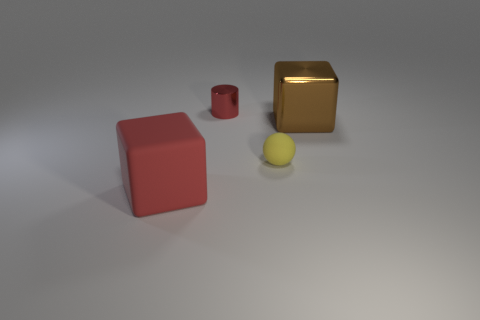What is the size of the object that is the same color as the big matte block?
Your answer should be compact. Small. What number of red things are left of the block that is on the right side of the red shiny cylinder?
Keep it short and to the point. 2. There is a yellow object; is it the same size as the rubber thing in front of the tiny yellow matte object?
Offer a very short reply. No. Are there any small cylinders of the same color as the big rubber cube?
Provide a short and direct response. Yes. There is another object that is the same material as the tiny yellow object; what size is it?
Your answer should be compact. Large. Is the material of the brown object the same as the red cylinder?
Your answer should be compact. Yes. What is the color of the object behind the large thing behind the matte thing left of the tiny rubber ball?
Keep it short and to the point. Red. What is the shape of the red metal object?
Give a very brief answer. Cylinder. Does the tiny shiny object have the same color as the big cube on the left side of the cylinder?
Provide a succinct answer. Yes. Are there an equal number of brown shiny things that are in front of the yellow matte sphere and big purple objects?
Provide a short and direct response. Yes. 